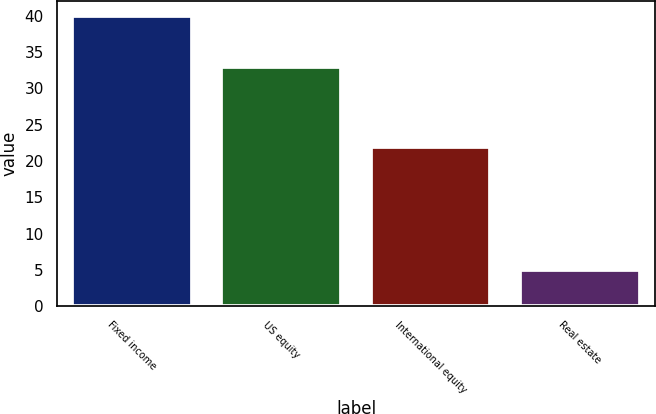Convert chart. <chart><loc_0><loc_0><loc_500><loc_500><bar_chart><fcel>Fixed income<fcel>US equity<fcel>International equity<fcel>Real estate<nl><fcel>40<fcel>33<fcel>22<fcel>5<nl></chart> 